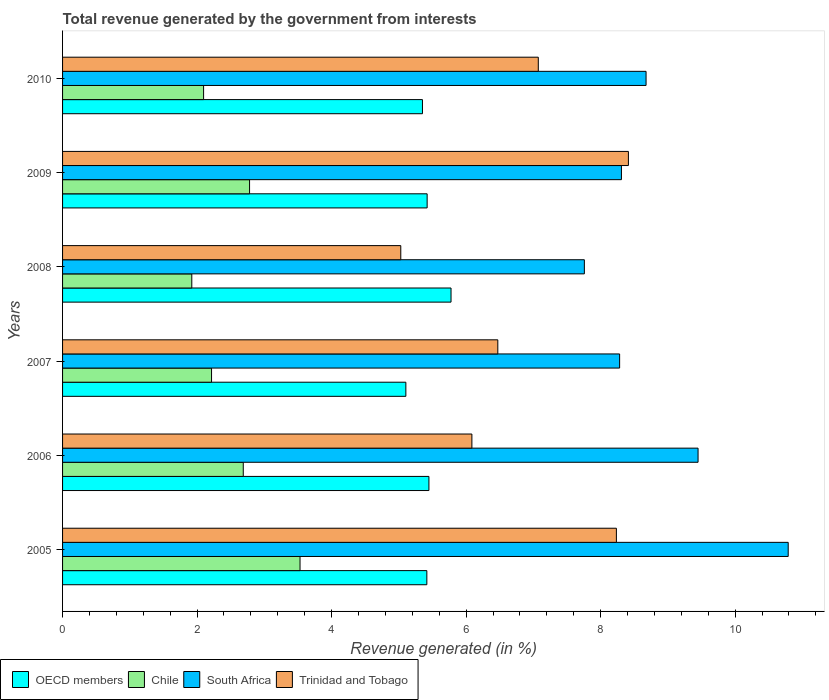How many different coloured bars are there?
Your answer should be very brief. 4. How many groups of bars are there?
Your answer should be very brief. 6. Are the number of bars on each tick of the Y-axis equal?
Offer a terse response. Yes. How many bars are there on the 3rd tick from the bottom?
Keep it short and to the point. 4. In how many cases, is the number of bars for a given year not equal to the number of legend labels?
Ensure brevity in your answer.  0. What is the total revenue generated in Trinidad and Tobago in 2008?
Ensure brevity in your answer.  5.03. Across all years, what is the maximum total revenue generated in Chile?
Provide a succinct answer. 3.53. Across all years, what is the minimum total revenue generated in South Africa?
Provide a short and direct response. 7.76. In which year was the total revenue generated in Chile maximum?
Keep it short and to the point. 2005. In which year was the total revenue generated in Trinidad and Tobago minimum?
Keep it short and to the point. 2008. What is the total total revenue generated in OECD members in the graph?
Offer a very short reply. 32.51. What is the difference between the total revenue generated in OECD members in 2008 and that in 2009?
Give a very brief answer. 0.36. What is the difference between the total revenue generated in South Africa in 2010 and the total revenue generated in OECD members in 2006?
Provide a succinct answer. 3.23. What is the average total revenue generated in South Africa per year?
Your answer should be very brief. 8.88. In the year 2007, what is the difference between the total revenue generated in Trinidad and Tobago and total revenue generated in South Africa?
Ensure brevity in your answer.  -1.81. What is the ratio of the total revenue generated in South Africa in 2005 to that in 2007?
Your response must be concise. 1.3. What is the difference between the highest and the second highest total revenue generated in OECD members?
Ensure brevity in your answer.  0.33. What is the difference between the highest and the lowest total revenue generated in Trinidad and Tobago?
Give a very brief answer. 3.38. Is the sum of the total revenue generated in Chile in 2005 and 2007 greater than the maximum total revenue generated in Trinidad and Tobago across all years?
Offer a terse response. No. What does the 3rd bar from the top in 2006 represents?
Your answer should be very brief. Chile. How many years are there in the graph?
Keep it short and to the point. 6. Does the graph contain any zero values?
Keep it short and to the point. No. Does the graph contain grids?
Your answer should be compact. No. How are the legend labels stacked?
Your answer should be compact. Horizontal. What is the title of the graph?
Keep it short and to the point. Total revenue generated by the government from interests. Does "Malaysia" appear as one of the legend labels in the graph?
Provide a succinct answer. No. What is the label or title of the X-axis?
Offer a very short reply. Revenue generated (in %). What is the Revenue generated (in %) in OECD members in 2005?
Provide a short and direct response. 5.42. What is the Revenue generated (in %) of Chile in 2005?
Offer a very short reply. 3.53. What is the Revenue generated (in %) in South Africa in 2005?
Provide a short and direct response. 10.79. What is the Revenue generated (in %) in Trinidad and Tobago in 2005?
Give a very brief answer. 8.23. What is the Revenue generated (in %) of OECD members in 2006?
Provide a short and direct response. 5.45. What is the Revenue generated (in %) in Chile in 2006?
Make the answer very short. 2.69. What is the Revenue generated (in %) in South Africa in 2006?
Give a very brief answer. 9.45. What is the Revenue generated (in %) in Trinidad and Tobago in 2006?
Your response must be concise. 6.09. What is the Revenue generated (in %) of OECD members in 2007?
Provide a succinct answer. 5.1. What is the Revenue generated (in %) of Chile in 2007?
Your answer should be very brief. 2.22. What is the Revenue generated (in %) of South Africa in 2007?
Give a very brief answer. 8.28. What is the Revenue generated (in %) of Trinidad and Tobago in 2007?
Offer a terse response. 6.47. What is the Revenue generated (in %) in OECD members in 2008?
Your response must be concise. 5.78. What is the Revenue generated (in %) of Chile in 2008?
Provide a succinct answer. 1.92. What is the Revenue generated (in %) of South Africa in 2008?
Offer a terse response. 7.76. What is the Revenue generated (in %) of Trinidad and Tobago in 2008?
Ensure brevity in your answer.  5.03. What is the Revenue generated (in %) in OECD members in 2009?
Provide a succinct answer. 5.42. What is the Revenue generated (in %) in Chile in 2009?
Offer a very short reply. 2.78. What is the Revenue generated (in %) of South Africa in 2009?
Provide a short and direct response. 8.31. What is the Revenue generated (in %) in Trinidad and Tobago in 2009?
Keep it short and to the point. 8.41. What is the Revenue generated (in %) in OECD members in 2010?
Your response must be concise. 5.35. What is the Revenue generated (in %) of Chile in 2010?
Your answer should be very brief. 2.1. What is the Revenue generated (in %) in South Africa in 2010?
Your answer should be compact. 8.68. What is the Revenue generated (in %) of Trinidad and Tobago in 2010?
Ensure brevity in your answer.  7.07. Across all years, what is the maximum Revenue generated (in %) in OECD members?
Give a very brief answer. 5.78. Across all years, what is the maximum Revenue generated (in %) in Chile?
Give a very brief answer. 3.53. Across all years, what is the maximum Revenue generated (in %) of South Africa?
Keep it short and to the point. 10.79. Across all years, what is the maximum Revenue generated (in %) of Trinidad and Tobago?
Make the answer very short. 8.41. Across all years, what is the minimum Revenue generated (in %) in OECD members?
Provide a succinct answer. 5.1. Across all years, what is the minimum Revenue generated (in %) of Chile?
Provide a succinct answer. 1.92. Across all years, what is the minimum Revenue generated (in %) of South Africa?
Offer a terse response. 7.76. Across all years, what is the minimum Revenue generated (in %) in Trinidad and Tobago?
Provide a short and direct response. 5.03. What is the total Revenue generated (in %) of OECD members in the graph?
Your answer should be compact. 32.51. What is the total Revenue generated (in %) in Chile in the graph?
Provide a succinct answer. 15.23. What is the total Revenue generated (in %) of South Africa in the graph?
Your answer should be very brief. 53.26. What is the total Revenue generated (in %) in Trinidad and Tobago in the graph?
Make the answer very short. 41.31. What is the difference between the Revenue generated (in %) of OECD members in 2005 and that in 2006?
Offer a very short reply. -0.03. What is the difference between the Revenue generated (in %) of Chile in 2005 and that in 2006?
Give a very brief answer. 0.84. What is the difference between the Revenue generated (in %) in South Africa in 2005 and that in 2006?
Provide a succinct answer. 1.34. What is the difference between the Revenue generated (in %) of Trinidad and Tobago in 2005 and that in 2006?
Your answer should be very brief. 2.15. What is the difference between the Revenue generated (in %) in OECD members in 2005 and that in 2007?
Ensure brevity in your answer.  0.31. What is the difference between the Revenue generated (in %) in Chile in 2005 and that in 2007?
Provide a short and direct response. 1.32. What is the difference between the Revenue generated (in %) in South Africa in 2005 and that in 2007?
Your response must be concise. 2.51. What is the difference between the Revenue generated (in %) in Trinidad and Tobago in 2005 and that in 2007?
Ensure brevity in your answer.  1.76. What is the difference between the Revenue generated (in %) in OECD members in 2005 and that in 2008?
Your answer should be very brief. -0.36. What is the difference between the Revenue generated (in %) in Chile in 2005 and that in 2008?
Provide a short and direct response. 1.61. What is the difference between the Revenue generated (in %) in South Africa in 2005 and that in 2008?
Your answer should be very brief. 3.03. What is the difference between the Revenue generated (in %) of Trinidad and Tobago in 2005 and that in 2008?
Provide a short and direct response. 3.21. What is the difference between the Revenue generated (in %) of OECD members in 2005 and that in 2009?
Your response must be concise. -0. What is the difference between the Revenue generated (in %) of Chile in 2005 and that in 2009?
Your answer should be compact. 0.75. What is the difference between the Revenue generated (in %) of South Africa in 2005 and that in 2009?
Offer a terse response. 2.48. What is the difference between the Revenue generated (in %) in Trinidad and Tobago in 2005 and that in 2009?
Your answer should be compact. -0.18. What is the difference between the Revenue generated (in %) of OECD members in 2005 and that in 2010?
Ensure brevity in your answer.  0.07. What is the difference between the Revenue generated (in %) in Chile in 2005 and that in 2010?
Give a very brief answer. 1.43. What is the difference between the Revenue generated (in %) in South Africa in 2005 and that in 2010?
Keep it short and to the point. 2.11. What is the difference between the Revenue generated (in %) of Trinidad and Tobago in 2005 and that in 2010?
Provide a short and direct response. 1.16. What is the difference between the Revenue generated (in %) in OECD members in 2006 and that in 2007?
Offer a terse response. 0.34. What is the difference between the Revenue generated (in %) in Chile in 2006 and that in 2007?
Offer a very short reply. 0.47. What is the difference between the Revenue generated (in %) in South Africa in 2006 and that in 2007?
Your answer should be very brief. 1.17. What is the difference between the Revenue generated (in %) of Trinidad and Tobago in 2006 and that in 2007?
Make the answer very short. -0.39. What is the difference between the Revenue generated (in %) in OECD members in 2006 and that in 2008?
Offer a very short reply. -0.33. What is the difference between the Revenue generated (in %) of Chile in 2006 and that in 2008?
Your answer should be compact. 0.77. What is the difference between the Revenue generated (in %) in South Africa in 2006 and that in 2008?
Offer a terse response. 1.69. What is the difference between the Revenue generated (in %) of Trinidad and Tobago in 2006 and that in 2008?
Give a very brief answer. 1.06. What is the difference between the Revenue generated (in %) of OECD members in 2006 and that in 2009?
Give a very brief answer. 0.03. What is the difference between the Revenue generated (in %) of Chile in 2006 and that in 2009?
Make the answer very short. -0.09. What is the difference between the Revenue generated (in %) of South Africa in 2006 and that in 2009?
Your response must be concise. 1.14. What is the difference between the Revenue generated (in %) in Trinidad and Tobago in 2006 and that in 2009?
Your response must be concise. -2.33. What is the difference between the Revenue generated (in %) in OECD members in 2006 and that in 2010?
Provide a succinct answer. 0.1. What is the difference between the Revenue generated (in %) in Chile in 2006 and that in 2010?
Your response must be concise. 0.59. What is the difference between the Revenue generated (in %) in South Africa in 2006 and that in 2010?
Offer a very short reply. 0.77. What is the difference between the Revenue generated (in %) in Trinidad and Tobago in 2006 and that in 2010?
Provide a short and direct response. -0.99. What is the difference between the Revenue generated (in %) of OECD members in 2007 and that in 2008?
Offer a very short reply. -0.67. What is the difference between the Revenue generated (in %) of Chile in 2007 and that in 2008?
Keep it short and to the point. 0.29. What is the difference between the Revenue generated (in %) of South Africa in 2007 and that in 2008?
Your answer should be compact. 0.52. What is the difference between the Revenue generated (in %) of Trinidad and Tobago in 2007 and that in 2008?
Offer a terse response. 1.44. What is the difference between the Revenue generated (in %) of OECD members in 2007 and that in 2009?
Your response must be concise. -0.32. What is the difference between the Revenue generated (in %) of Chile in 2007 and that in 2009?
Give a very brief answer. -0.57. What is the difference between the Revenue generated (in %) in South Africa in 2007 and that in 2009?
Your response must be concise. -0.03. What is the difference between the Revenue generated (in %) in Trinidad and Tobago in 2007 and that in 2009?
Offer a terse response. -1.94. What is the difference between the Revenue generated (in %) of OECD members in 2007 and that in 2010?
Keep it short and to the point. -0.25. What is the difference between the Revenue generated (in %) of Chile in 2007 and that in 2010?
Give a very brief answer. 0.12. What is the difference between the Revenue generated (in %) of South Africa in 2007 and that in 2010?
Your answer should be very brief. -0.39. What is the difference between the Revenue generated (in %) in Trinidad and Tobago in 2007 and that in 2010?
Give a very brief answer. -0.6. What is the difference between the Revenue generated (in %) in OECD members in 2008 and that in 2009?
Your answer should be compact. 0.36. What is the difference between the Revenue generated (in %) in Chile in 2008 and that in 2009?
Provide a short and direct response. -0.86. What is the difference between the Revenue generated (in %) of South Africa in 2008 and that in 2009?
Provide a short and direct response. -0.55. What is the difference between the Revenue generated (in %) of Trinidad and Tobago in 2008 and that in 2009?
Your answer should be very brief. -3.38. What is the difference between the Revenue generated (in %) of OECD members in 2008 and that in 2010?
Give a very brief answer. 0.42. What is the difference between the Revenue generated (in %) in Chile in 2008 and that in 2010?
Offer a very short reply. -0.18. What is the difference between the Revenue generated (in %) in South Africa in 2008 and that in 2010?
Keep it short and to the point. -0.92. What is the difference between the Revenue generated (in %) of Trinidad and Tobago in 2008 and that in 2010?
Offer a very short reply. -2.04. What is the difference between the Revenue generated (in %) of OECD members in 2009 and that in 2010?
Offer a terse response. 0.07. What is the difference between the Revenue generated (in %) of Chile in 2009 and that in 2010?
Offer a terse response. 0.68. What is the difference between the Revenue generated (in %) in South Africa in 2009 and that in 2010?
Make the answer very short. -0.37. What is the difference between the Revenue generated (in %) of Trinidad and Tobago in 2009 and that in 2010?
Provide a short and direct response. 1.34. What is the difference between the Revenue generated (in %) in OECD members in 2005 and the Revenue generated (in %) in Chile in 2006?
Your response must be concise. 2.73. What is the difference between the Revenue generated (in %) of OECD members in 2005 and the Revenue generated (in %) of South Africa in 2006?
Your answer should be compact. -4.03. What is the difference between the Revenue generated (in %) in OECD members in 2005 and the Revenue generated (in %) in Trinidad and Tobago in 2006?
Your answer should be compact. -0.67. What is the difference between the Revenue generated (in %) in Chile in 2005 and the Revenue generated (in %) in South Africa in 2006?
Provide a succinct answer. -5.92. What is the difference between the Revenue generated (in %) in Chile in 2005 and the Revenue generated (in %) in Trinidad and Tobago in 2006?
Your answer should be very brief. -2.56. What is the difference between the Revenue generated (in %) of South Africa in 2005 and the Revenue generated (in %) of Trinidad and Tobago in 2006?
Offer a very short reply. 4.7. What is the difference between the Revenue generated (in %) in OECD members in 2005 and the Revenue generated (in %) in Chile in 2007?
Provide a short and direct response. 3.2. What is the difference between the Revenue generated (in %) in OECD members in 2005 and the Revenue generated (in %) in South Africa in 2007?
Offer a terse response. -2.87. What is the difference between the Revenue generated (in %) of OECD members in 2005 and the Revenue generated (in %) of Trinidad and Tobago in 2007?
Ensure brevity in your answer.  -1.06. What is the difference between the Revenue generated (in %) in Chile in 2005 and the Revenue generated (in %) in South Africa in 2007?
Keep it short and to the point. -4.75. What is the difference between the Revenue generated (in %) in Chile in 2005 and the Revenue generated (in %) in Trinidad and Tobago in 2007?
Keep it short and to the point. -2.94. What is the difference between the Revenue generated (in %) of South Africa in 2005 and the Revenue generated (in %) of Trinidad and Tobago in 2007?
Your response must be concise. 4.32. What is the difference between the Revenue generated (in %) of OECD members in 2005 and the Revenue generated (in %) of Chile in 2008?
Ensure brevity in your answer.  3.49. What is the difference between the Revenue generated (in %) in OECD members in 2005 and the Revenue generated (in %) in South Africa in 2008?
Make the answer very short. -2.34. What is the difference between the Revenue generated (in %) of OECD members in 2005 and the Revenue generated (in %) of Trinidad and Tobago in 2008?
Offer a terse response. 0.39. What is the difference between the Revenue generated (in %) in Chile in 2005 and the Revenue generated (in %) in South Africa in 2008?
Your answer should be very brief. -4.23. What is the difference between the Revenue generated (in %) of Chile in 2005 and the Revenue generated (in %) of Trinidad and Tobago in 2008?
Provide a succinct answer. -1.5. What is the difference between the Revenue generated (in %) in South Africa in 2005 and the Revenue generated (in %) in Trinidad and Tobago in 2008?
Provide a succinct answer. 5.76. What is the difference between the Revenue generated (in %) in OECD members in 2005 and the Revenue generated (in %) in Chile in 2009?
Provide a short and direct response. 2.64. What is the difference between the Revenue generated (in %) in OECD members in 2005 and the Revenue generated (in %) in South Africa in 2009?
Keep it short and to the point. -2.89. What is the difference between the Revenue generated (in %) of OECD members in 2005 and the Revenue generated (in %) of Trinidad and Tobago in 2009?
Offer a terse response. -3. What is the difference between the Revenue generated (in %) in Chile in 2005 and the Revenue generated (in %) in South Africa in 2009?
Provide a succinct answer. -4.78. What is the difference between the Revenue generated (in %) of Chile in 2005 and the Revenue generated (in %) of Trinidad and Tobago in 2009?
Your response must be concise. -4.88. What is the difference between the Revenue generated (in %) in South Africa in 2005 and the Revenue generated (in %) in Trinidad and Tobago in 2009?
Offer a very short reply. 2.38. What is the difference between the Revenue generated (in %) in OECD members in 2005 and the Revenue generated (in %) in Chile in 2010?
Your answer should be compact. 3.32. What is the difference between the Revenue generated (in %) of OECD members in 2005 and the Revenue generated (in %) of South Africa in 2010?
Your response must be concise. -3.26. What is the difference between the Revenue generated (in %) of OECD members in 2005 and the Revenue generated (in %) of Trinidad and Tobago in 2010?
Your answer should be compact. -1.66. What is the difference between the Revenue generated (in %) in Chile in 2005 and the Revenue generated (in %) in South Africa in 2010?
Make the answer very short. -5.14. What is the difference between the Revenue generated (in %) of Chile in 2005 and the Revenue generated (in %) of Trinidad and Tobago in 2010?
Make the answer very short. -3.54. What is the difference between the Revenue generated (in %) in South Africa in 2005 and the Revenue generated (in %) in Trinidad and Tobago in 2010?
Give a very brief answer. 3.72. What is the difference between the Revenue generated (in %) in OECD members in 2006 and the Revenue generated (in %) in Chile in 2007?
Give a very brief answer. 3.23. What is the difference between the Revenue generated (in %) in OECD members in 2006 and the Revenue generated (in %) in South Africa in 2007?
Your answer should be very brief. -2.84. What is the difference between the Revenue generated (in %) of OECD members in 2006 and the Revenue generated (in %) of Trinidad and Tobago in 2007?
Make the answer very short. -1.02. What is the difference between the Revenue generated (in %) in Chile in 2006 and the Revenue generated (in %) in South Africa in 2007?
Offer a very short reply. -5.6. What is the difference between the Revenue generated (in %) in Chile in 2006 and the Revenue generated (in %) in Trinidad and Tobago in 2007?
Your answer should be compact. -3.78. What is the difference between the Revenue generated (in %) in South Africa in 2006 and the Revenue generated (in %) in Trinidad and Tobago in 2007?
Provide a short and direct response. 2.98. What is the difference between the Revenue generated (in %) of OECD members in 2006 and the Revenue generated (in %) of Chile in 2008?
Ensure brevity in your answer.  3.53. What is the difference between the Revenue generated (in %) of OECD members in 2006 and the Revenue generated (in %) of South Africa in 2008?
Keep it short and to the point. -2.31. What is the difference between the Revenue generated (in %) in OECD members in 2006 and the Revenue generated (in %) in Trinidad and Tobago in 2008?
Give a very brief answer. 0.42. What is the difference between the Revenue generated (in %) in Chile in 2006 and the Revenue generated (in %) in South Africa in 2008?
Keep it short and to the point. -5.07. What is the difference between the Revenue generated (in %) in Chile in 2006 and the Revenue generated (in %) in Trinidad and Tobago in 2008?
Provide a short and direct response. -2.34. What is the difference between the Revenue generated (in %) in South Africa in 2006 and the Revenue generated (in %) in Trinidad and Tobago in 2008?
Keep it short and to the point. 4.42. What is the difference between the Revenue generated (in %) of OECD members in 2006 and the Revenue generated (in %) of Chile in 2009?
Provide a short and direct response. 2.67. What is the difference between the Revenue generated (in %) of OECD members in 2006 and the Revenue generated (in %) of South Africa in 2009?
Give a very brief answer. -2.86. What is the difference between the Revenue generated (in %) of OECD members in 2006 and the Revenue generated (in %) of Trinidad and Tobago in 2009?
Make the answer very short. -2.97. What is the difference between the Revenue generated (in %) in Chile in 2006 and the Revenue generated (in %) in South Africa in 2009?
Make the answer very short. -5.62. What is the difference between the Revenue generated (in %) of Chile in 2006 and the Revenue generated (in %) of Trinidad and Tobago in 2009?
Provide a succinct answer. -5.73. What is the difference between the Revenue generated (in %) of South Africa in 2006 and the Revenue generated (in %) of Trinidad and Tobago in 2009?
Your answer should be compact. 1.04. What is the difference between the Revenue generated (in %) of OECD members in 2006 and the Revenue generated (in %) of Chile in 2010?
Provide a succinct answer. 3.35. What is the difference between the Revenue generated (in %) in OECD members in 2006 and the Revenue generated (in %) in South Africa in 2010?
Provide a short and direct response. -3.23. What is the difference between the Revenue generated (in %) of OECD members in 2006 and the Revenue generated (in %) of Trinidad and Tobago in 2010?
Make the answer very short. -1.63. What is the difference between the Revenue generated (in %) of Chile in 2006 and the Revenue generated (in %) of South Africa in 2010?
Keep it short and to the point. -5.99. What is the difference between the Revenue generated (in %) in Chile in 2006 and the Revenue generated (in %) in Trinidad and Tobago in 2010?
Ensure brevity in your answer.  -4.39. What is the difference between the Revenue generated (in %) in South Africa in 2006 and the Revenue generated (in %) in Trinidad and Tobago in 2010?
Offer a very short reply. 2.38. What is the difference between the Revenue generated (in %) in OECD members in 2007 and the Revenue generated (in %) in Chile in 2008?
Provide a succinct answer. 3.18. What is the difference between the Revenue generated (in %) in OECD members in 2007 and the Revenue generated (in %) in South Africa in 2008?
Provide a short and direct response. -2.65. What is the difference between the Revenue generated (in %) of OECD members in 2007 and the Revenue generated (in %) of Trinidad and Tobago in 2008?
Provide a succinct answer. 0.08. What is the difference between the Revenue generated (in %) of Chile in 2007 and the Revenue generated (in %) of South Africa in 2008?
Your answer should be compact. -5.54. What is the difference between the Revenue generated (in %) in Chile in 2007 and the Revenue generated (in %) in Trinidad and Tobago in 2008?
Your answer should be very brief. -2.81. What is the difference between the Revenue generated (in %) in South Africa in 2007 and the Revenue generated (in %) in Trinidad and Tobago in 2008?
Your answer should be very brief. 3.25. What is the difference between the Revenue generated (in %) in OECD members in 2007 and the Revenue generated (in %) in Chile in 2009?
Provide a short and direct response. 2.32. What is the difference between the Revenue generated (in %) of OECD members in 2007 and the Revenue generated (in %) of South Africa in 2009?
Ensure brevity in your answer.  -3.21. What is the difference between the Revenue generated (in %) in OECD members in 2007 and the Revenue generated (in %) in Trinidad and Tobago in 2009?
Your answer should be very brief. -3.31. What is the difference between the Revenue generated (in %) in Chile in 2007 and the Revenue generated (in %) in South Africa in 2009?
Offer a terse response. -6.09. What is the difference between the Revenue generated (in %) of Chile in 2007 and the Revenue generated (in %) of Trinidad and Tobago in 2009?
Provide a succinct answer. -6.2. What is the difference between the Revenue generated (in %) of South Africa in 2007 and the Revenue generated (in %) of Trinidad and Tobago in 2009?
Provide a short and direct response. -0.13. What is the difference between the Revenue generated (in %) of OECD members in 2007 and the Revenue generated (in %) of Chile in 2010?
Offer a terse response. 3.01. What is the difference between the Revenue generated (in %) in OECD members in 2007 and the Revenue generated (in %) in South Africa in 2010?
Your answer should be very brief. -3.57. What is the difference between the Revenue generated (in %) in OECD members in 2007 and the Revenue generated (in %) in Trinidad and Tobago in 2010?
Offer a very short reply. -1.97. What is the difference between the Revenue generated (in %) of Chile in 2007 and the Revenue generated (in %) of South Africa in 2010?
Your answer should be compact. -6.46. What is the difference between the Revenue generated (in %) of Chile in 2007 and the Revenue generated (in %) of Trinidad and Tobago in 2010?
Your answer should be very brief. -4.86. What is the difference between the Revenue generated (in %) of South Africa in 2007 and the Revenue generated (in %) of Trinidad and Tobago in 2010?
Give a very brief answer. 1.21. What is the difference between the Revenue generated (in %) in OECD members in 2008 and the Revenue generated (in %) in Chile in 2009?
Ensure brevity in your answer.  3. What is the difference between the Revenue generated (in %) in OECD members in 2008 and the Revenue generated (in %) in South Africa in 2009?
Ensure brevity in your answer.  -2.53. What is the difference between the Revenue generated (in %) of OECD members in 2008 and the Revenue generated (in %) of Trinidad and Tobago in 2009?
Your response must be concise. -2.64. What is the difference between the Revenue generated (in %) of Chile in 2008 and the Revenue generated (in %) of South Africa in 2009?
Your response must be concise. -6.39. What is the difference between the Revenue generated (in %) in Chile in 2008 and the Revenue generated (in %) in Trinidad and Tobago in 2009?
Give a very brief answer. -6.49. What is the difference between the Revenue generated (in %) of South Africa in 2008 and the Revenue generated (in %) of Trinidad and Tobago in 2009?
Give a very brief answer. -0.66. What is the difference between the Revenue generated (in %) of OECD members in 2008 and the Revenue generated (in %) of Chile in 2010?
Ensure brevity in your answer.  3.68. What is the difference between the Revenue generated (in %) of OECD members in 2008 and the Revenue generated (in %) of South Africa in 2010?
Ensure brevity in your answer.  -2.9. What is the difference between the Revenue generated (in %) in OECD members in 2008 and the Revenue generated (in %) in Trinidad and Tobago in 2010?
Offer a very short reply. -1.3. What is the difference between the Revenue generated (in %) in Chile in 2008 and the Revenue generated (in %) in South Africa in 2010?
Your answer should be compact. -6.75. What is the difference between the Revenue generated (in %) in Chile in 2008 and the Revenue generated (in %) in Trinidad and Tobago in 2010?
Your response must be concise. -5.15. What is the difference between the Revenue generated (in %) in South Africa in 2008 and the Revenue generated (in %) in Trinidad and Tobago in 2010?
Ensure brevity in your answer.  0.68. What is the difference between the Revenue generated (in %) in OECD members in 2009 and the Revenue generated (in %) in Chile in 2010?
Offer a very short reply. 3.32. What is the difference between the Revenue generated (in %) of OECD members in 2009 and the Revenue generated (in %) of South Africa in 2010?
Provide a succinct answer. -3.26. What is the difference between the Revenue generated (in %) in OECD members in 2009 and the Revenue generated (in %) in Trinidad and Tobago in 2010?
Make the answer very short. -1.65. What is the difference between the Revenue generated (in %) of Chile in 2009 and the Revenue generated (in %) of South Africa in 2010?
Make the answer very short. -5.9. What is the difference between the Revenue generated (in %) of Chile in 2009 and the Revenue generated (in %) of Trinidad and Tobago in 2010?
Offer a very short reply. -4.29. What is the difference between the Revenue generated (in %) in South Africa in 2009 and the Revenue generated (in %) in Trinidad and Tobago in 2010?
Offer a very short reply. 1.24. What is the average Revenue generated (in %) of OECD members per year?
Ensure brevity in your answer.  5.42. What is the average Revenue generated (in %) in Chile per year?
Give a very brief answer. 2.54. What is the average Revenue generated (in %) in South Africa per year?
Ensure brevity in your answer.  8.88. What is the average Revenue generated (in %) of Trinidad and Tobago per year?
Provide a succinct answer. 6.88. In the year 2005, what is the difference between the Revenue generated (in %) of OECD members and Revenue generated (in %) of Chile?
Give a very brief answer. 1.89. In the year 2005, what is the difference between the Revenue generated (in %) of OECD members and Revenue generated (in %) of South Africa?
Ensure brevity in your answer.  -5.37. In the year 2005, what is the difference between the Revenue generated (in %) in OECD members and Revenue generated (in %) in Trinidad and Tobago?
Make the answer very short. -2.82. In the year 2005, what is the difference between the Revenue generated (in %) in Chile and Revenue generated (in %) in South Africa?
Give a very brief answer. -7.26. In the year 2005, what is the difference between the Revenue generated (in %) of Chile and Revenue generated (in %) of Trinidad and Tobago?
Keep it short and to the point. -4.7. In the year 2005, what is the difference between the Revenue generated (in %) in South Africa and Revenue generated (in %) in Trinidad and Tobago?
Your answer should be very brief. 2.55. In the year 2006, what is the difference between the Revenue generated (in %) in OECD members and Revenue generated (in %) in Chile?
Your response must be concise. 2.76. In the year 2006, what is the difference between the Revenue generated (in %) in OECD members and Revenue generated (in %) in South Africa?
Your answer should be very brief. -4. In the year 2006, what is the difference between the Revenue generated (in %) in OECD members and Revenue generated (in %) in Trinidad and Tobago?
Offer a very short reply. -0.64. In the year 2006, what is the difference between the Revenue generated (in %) in Chile and Revenue generated (in %) in South Africa?
Ensure brevity in your answer.  -6.76. In the year 2006, what is the difference between the Revenue generated (in %) in Chile and Revenue generated (in %) in Trinidad and Tobago?
Make the answer very short. -3.4. In the year 2006, what is the difference between the Revenue generated (in %) of South Africa and Revenue generated (in %) of Trinidad and Tobago?
Offer a terse response. 3.36. In the year 2007, what is the difference between the Revenue generated (in %) in OECD members and Revenue generated (in %) in Chile?
Provide a succinct answer. 2.89. In the year 2007, what is the difference between the Revenue generated (in %) in OECD members and Revenue generated (in %) in South Africa?
Give a very brief answer. -3.18. In the year 2007, what is the difference between the Revenue generated (in %) of OECD members and Revenue generated (in %) of Trinidad and Tobago?
Make the answer very short. -1.37. In the year 2007, what is the difference between the Revenue generated (in %) in Chile and Revenue generated (in %) in South Africa?
Your response must be concise. -6.07. In the year 2007, what is the difference between the Revenue generated (in %) in Chile and Revenue generated (in %) in Trinidad and Tobago?
Your answer should be very brief. -4.26. In the year 2007, what is the difference between the Revenue generated (in %) of South Africa and Revenue generated (in %) of Trinidad and Tobago?
Your response must be concise. 1.81. In the year 2008, what is the difference between the Revenue generated (in %) of OECD members and Revenue generated (in %) of Chile?
Your answer should be very brief. 3.85. In the year 2008, what is the difference between the Revenue generated (in %) of OECD members and Revenue generated (in %) of South Africa?
Your response must be concise. -1.98. In the year 2008, what is the difference between the Revenue generated (in %) in OECD members and Revenue generated (in %) in Trinidad and Tobago?
Ensure brevity in your answer.  0.75. In the year 2008, what is the difference between the Revenue generated (in %) in Chile and Revenue generated (in %) in South Africa?
Give a very brief answer. -5.84. In the year 2008, what is the difference between the Revenue generated (in %) of Chile and Revenue generated (in %) of Trinidad and Tobago?
Keep it short and to the point. -3.11. In the year 2008, what is the difference between the Revenue generated (in %) in South Africa and Revenue generated (in %) in Trinidad and Tobago?
Your response must be concise. 2.73. In the year 2009, what is the difference between the Revenue generated (in %) in OECD members and Revenue generated (in %) in Chile?
Give a very brief answer. 2.64. In the year 2009, what is the difference between the Revenue generated (in %) of OECD members and Revenue generated (in %) of South Africa?
Make the answer very short. -2.89. In the year 2009, what is the difference between the Revenue generated (in %) in OECD members and Revenue generated (in %) in Trinidad and Tobago?
Provide a short and direct response. -2.99. In the year 2009, what is the difference between the Revenue generated (in %) of Chile and Revenue generated (in %) of South Africa?
Provide a short and direct response. -5.53. In the year 2009, what is the difference between the Revenue generated (in %) of Chile and Revenue generated (in %) of Trinidad and Tobago?
Ensure brevity in your answer.  -5.63. In the year 2009, what is the difference between the Revenue generated (in %) in South Africa and Revenue generated (in %) in Trinidad and Tobago?
Your answer should be compact. -0.1. In the year 2010, what is the difference between the Revenue generated (in %) of OECD members and Revenue generated (in %) of Chile?
Offer a very short reply. 3.25. In the year 2010, what is the difference between the Revenue generated (in %) of OECD members and Revenue generated (in %) of South Africa?
Your answer should be very brief. -3.32. In the year 2010, what is the difference between the Revenue generated (in %) in OECD members and Revenue generated (in %) in Trinidad and Tobago?
Offer a terse response. -1.72. In the year 2010, what is the difference between the Revenue generated (in %) in Chile and Revenue generated (in %) in South Africa?
Ensure brevity in your answer.  -6.58. In the year 2010, what is the difference between the Revenue generated (in %) in Chile and Revenue generated (in %) in Trinidad and Tobago?
Keep it short and to the point. -4.98. In the year 2010, what is the difference between the Revenue generated (in %) in South Africa and Revenue generated (in %) in Trinidad and Tobago?
Offer a very short reply. 1.6. What is the ratio of the Revenue generated (in %) of Chile in 2005 to that in 2006?
Your response must be concise. 1.31. What is the ratio of the Revenue generated (in %) in South Africa in 2005 to that in 2006?
Make the answer very short. 1.14. What is the ratio of the Revenue generated (in %) in Trinidad and Tobago in 2005 to that in 2006?
Your answer should be compact. 1.35. What is the ratio of the Revenue generated (in %) of OECD members in 2005 to that in 2007?
Your answer should be very brief. 1.06. What is the ratio of the Revenue generated (in %) of Chile in 2005 to that in 2007?
Make the answer very short. 1.59. What is the ratio of the Revenue generated (in %) in South Africa in 2005 to that in 2007?
Offer a very short reply. 1.3. What is the ratio of the Revenue generated (in %) in Trinidad and Tobago in 2005 to that in 2007?
Your answer should be compact. 1.27. What is the ratio of the Revenue generated (in %) in OECD members in 2005 to that in 2008?
Your answer should be compact. 0.94. What is the ratio of the Revenue generated (in %) in Chile in 2005 to that in 2008?
Give a very brief answer. 1.84. What is the ratio of the Revenue generated (in %) of South Africa in 2005 to that in 2008?
Make the answer very short. 1.39. What is the ratio of the Revenue generated (in %) in Trinidad and Tobago in 2005 to that in 2008?
Provide a short and direct response. 1.64. What is the ratio of the Revenue generated (in %) of Chile in 2005 to that in 2009?
Your answer should be very brief. 1.27. What is the ratio of the Revenue generated (in %) of South Africa in 2005 to that in 2009?
Your response must be concise. 1.3. What is the ratio of the Revenue generated (in %) in Trinidad and Tobago in 2005 to that in 2009?
Give a very brief answer. 0.98. What is the ratio of the Revenue generated (in %) in OECD members in 2005 to that in 2010?
Give a very brief answer. 1.01. What is the ratio of the Revenue generated (in %) in Chile in 2005 to that in 2010?
Give a very brief answer. 1.68. What is the ratio of the Revenue generated (in %) of South Africa in 2005 to that in 2010?
Your answer should be very brief. 1.24. What is the ratio of the Revenue generated (in %) of Trinidad and Tobago in 2005 to that in 2010?
Your answer should be compact. 1.16. What is the ratio of the Revenue generated (in %) of OECD members in 2006 to that in 2007?
Provide a short and direct response. 1.07. What is the ratio of the Revenue generated (in %) of Chile in 2006 to that in 2007?
Provide a succinct answer. 1.21. What is the ratio of the Revenue generated (in %) of South Africa in 2006 to that in 2007?
Provide a succinct answer. 1.14. What is the ratio of the Revenue generated (in %) of Trinidad and Tobago in 2006 to that in 2007?
Your answer should be compact. 0.94. What is the ratio of the Revenue generated (in %) in OECD members in 2006 to that in 2008?
Your answer should be very brief. 0.94. What is the ratio of the Revenue generated (in %) of Chile in 2006 to that in 2008?
Make the answer very short. 1.4. What is the ratio of the Revenue generated (in %) of South Africa in 2006 to that in 2008?
Give a very brief answer. 1.22. What is the ratio of the Revenue generated (in %) of Trinidad and Tobago in 2006 to that in 2008?
Keep it short and to the point. 1.21. What is the ratio of the Revenue generated (in %) in OECD members in 2006 to that in 2009?
Offer a very short reply. 1. What is the ratio of the Revenue generated (in %) of Chile in 2006 to that in 2009?
Provide a short and direct response. 0.97. What is the ratio of the Revenue generated (in %) of South Africa in 2006 to that in 2009?
Make the answer very short. 1.14. What is the ratio of the Revenue generated (in %) of Trinidad and Tobago in 2006 to that in 2009?
Ensure brevity in your answer.  0.72. What is the ratio of the Revenue generated (in %) in Chile in 2006 to that in 2010?
Ensure brevity in your answer.  1.28. What is the ratio of the Revenue generated (in %) of South Africa in 2006 to that in 2010?
Ensure brevity in your answer.  1.09. What is the ratio of the Revenue generated (in %) of Trinidad and Tobago in 2006 to that in 2010?
Provide a short and direct response. 0.86. What is the ratio of the Revenue generated (in %) in OECD members in 2007 to that in 2008?
Make the answer very short. 0.88. What is the ratio of the Revenue generated (in %) of Chile in 2007 to that in 2008?
Your answer should be very brief. 1.15. What is the ratio of the Revenue generated (in %) of South Africa in 2007 to that in 2008?
Give a very brief answer. 1.07. What is the ratio of the Revenue generated (in %) of Trinidad and Tobago in 2007 to that in 2008?
Provide a short and direct response. 1.29. What is the ratio of the Revenue generated (in %) in OECD members in 2007 to that in 2009?
Give a very brief answer. 0.94. What is the ratio of the Revenue generated (in %) of Chile in 2007 to that in 2009?
Your answer should be very brief. 0.8. What is the ratio of the Revenue generated (in %) in Trinidad and Tobago in 2007 to that in 2009?
Your answer should be compact. 0.77. What is the ratio of the Revenue generated (in %) in OECD members in 2007 to that in 2010?
Ensure brevity in your answer.  0.95. What is the ratio of the Revenue generated (in %) of Chile in 2007 to that in 2010?
Your answer should be very brief. 1.06. What is the ratio of the Revenue generated (in %) in South Africa in 2007 to that in 2010?
Provide a succinct answer. 0.95. What is the ratio of the Revenue generated (in %) in Trinidad and Tobago in 2007 to that in 2010?
Keep it short and to the point. 0.91. What is the ratio of the Revenue generated (in %) in OECD members in 2008 to that in 2009?
Provide a succinct answer. 1.07. What is the ratio of the Revenue generated (in %) in Chile in 2008 to that in 2009?
Your answer should be compact. 0.69. What is the ratio of the Revenue generated (in %) in South Africa in 2008 to that in 2009?
Make the answer very short. 0.93. What is the ratio of the Revenue generated (in %) in Trinidad and Tobago in 2008 to that in 2009?
Provide a succinct answer. 0.6. What is the ratio of the Revenue generated (in %) in OECD members in 2008 to that in 2010?
Provide a succinct answer. 1.08. What is the ratio of the Revenue generated (in %) of Chile in 2008 to that in 2010?
Your answer should be compact. 0.92. What is the ratio of the Revenue generated (in %) in South Africa in 2008 to that in 2010?
Your answer should be compact. 0.89. What is the ratio of the Revenue generated (in %) of Trinidad and Tobago in 2008 to that in 2010?
Provide a short and direct response. 0.71. What is the ratio of the Revenue generated (in %) of OECD members in 2009 to that in 2010?
Ensure brevity in your answer.  1.01. What is the ratio of the Revenue generated (in %) in Chile in 2009 to that in 2010?
Keep it short and to the point. 1.33. What is the ratio of the Revenue generated (in %) in South Africa in 2009 to that in 2010?
Keep it short and to the point. 0.96. What is the ratio of the Revenue generated (in %) in Trinidad and Tobago in 2009 to that in 2010?
Provide a succinct answer. 1.19. What is the difference between the highest and the second highest Revenue generated (in %) of OECD members?
Keep it short and to the point. 0.33. What is the difference between the highest and the second highest Revenue generated (in %) in Chile?
Your answer should be very brief. 0.75. What is the difference between the highest and the second highest Revenue generated (in %) in South Africa?
Offer a very short reply. 1.34. What is the difference between the highest and the second highest Revenue generated (in %) in Trinidad and Tobago?
Your response must be concise. 0.18. What is the difference between the highest and the lowest Revenue generated (in %) in OECD members?
Provide a succinct answer. 0.67. What is the difference between the highest and the lowest Revenue generated (in %) in Chile?
Ensure brevity in your answer.  1.61. What is the difference between the highest and the lowest Revenue generated (in %) in South Africa?
Keep it short and to the point. 3.03. What is the difference between the highest and the lowest Revenue generated (in %) of Trinidad and Tobago?
Provide a short and direct response. 3.38. 